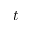Convert formula to latex. <formula><loc_0><loc_0><loc_500><loc_500>t</formula> 